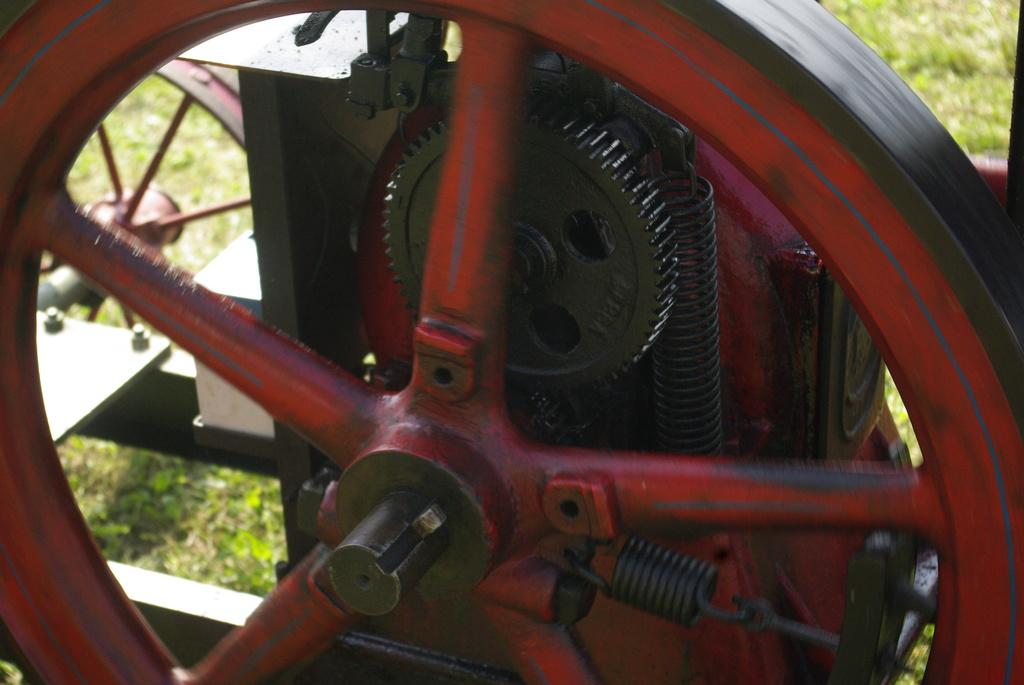What mechanical component can be seen in the image? There is a wheel in the image. What other mechanical component is present in the image? There is a gear in the image. What type of elastic material is visible in the image? There are springs in the image. What type of natural environment is visible in the background of the image? There is grass in the background of the image. What type of statement can be seen written on the gear in the image? There are no statements written on the gear in the image; it is a mechanical component. 